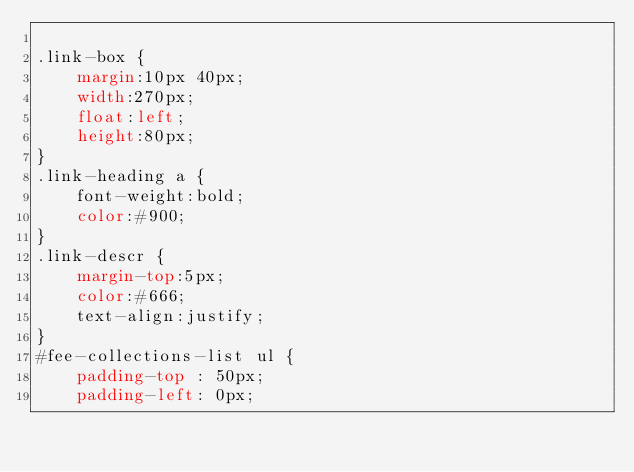<code> <loc_0><loc_0><loc_500><loc_500><_CSS_>
.link-box {
    margin:10px 40px;
    width:270px;
    float:left;
    height:80px;
}
.link-heading a {
    font-weight:bold;
    color:#900;
}
.link-descr {
    margin-top:5px;
    color:#666;
    text-align:justify;
}
#fee-collections-list ul {
    padding-top : 50px;
    padding-left: 0px;</code> 